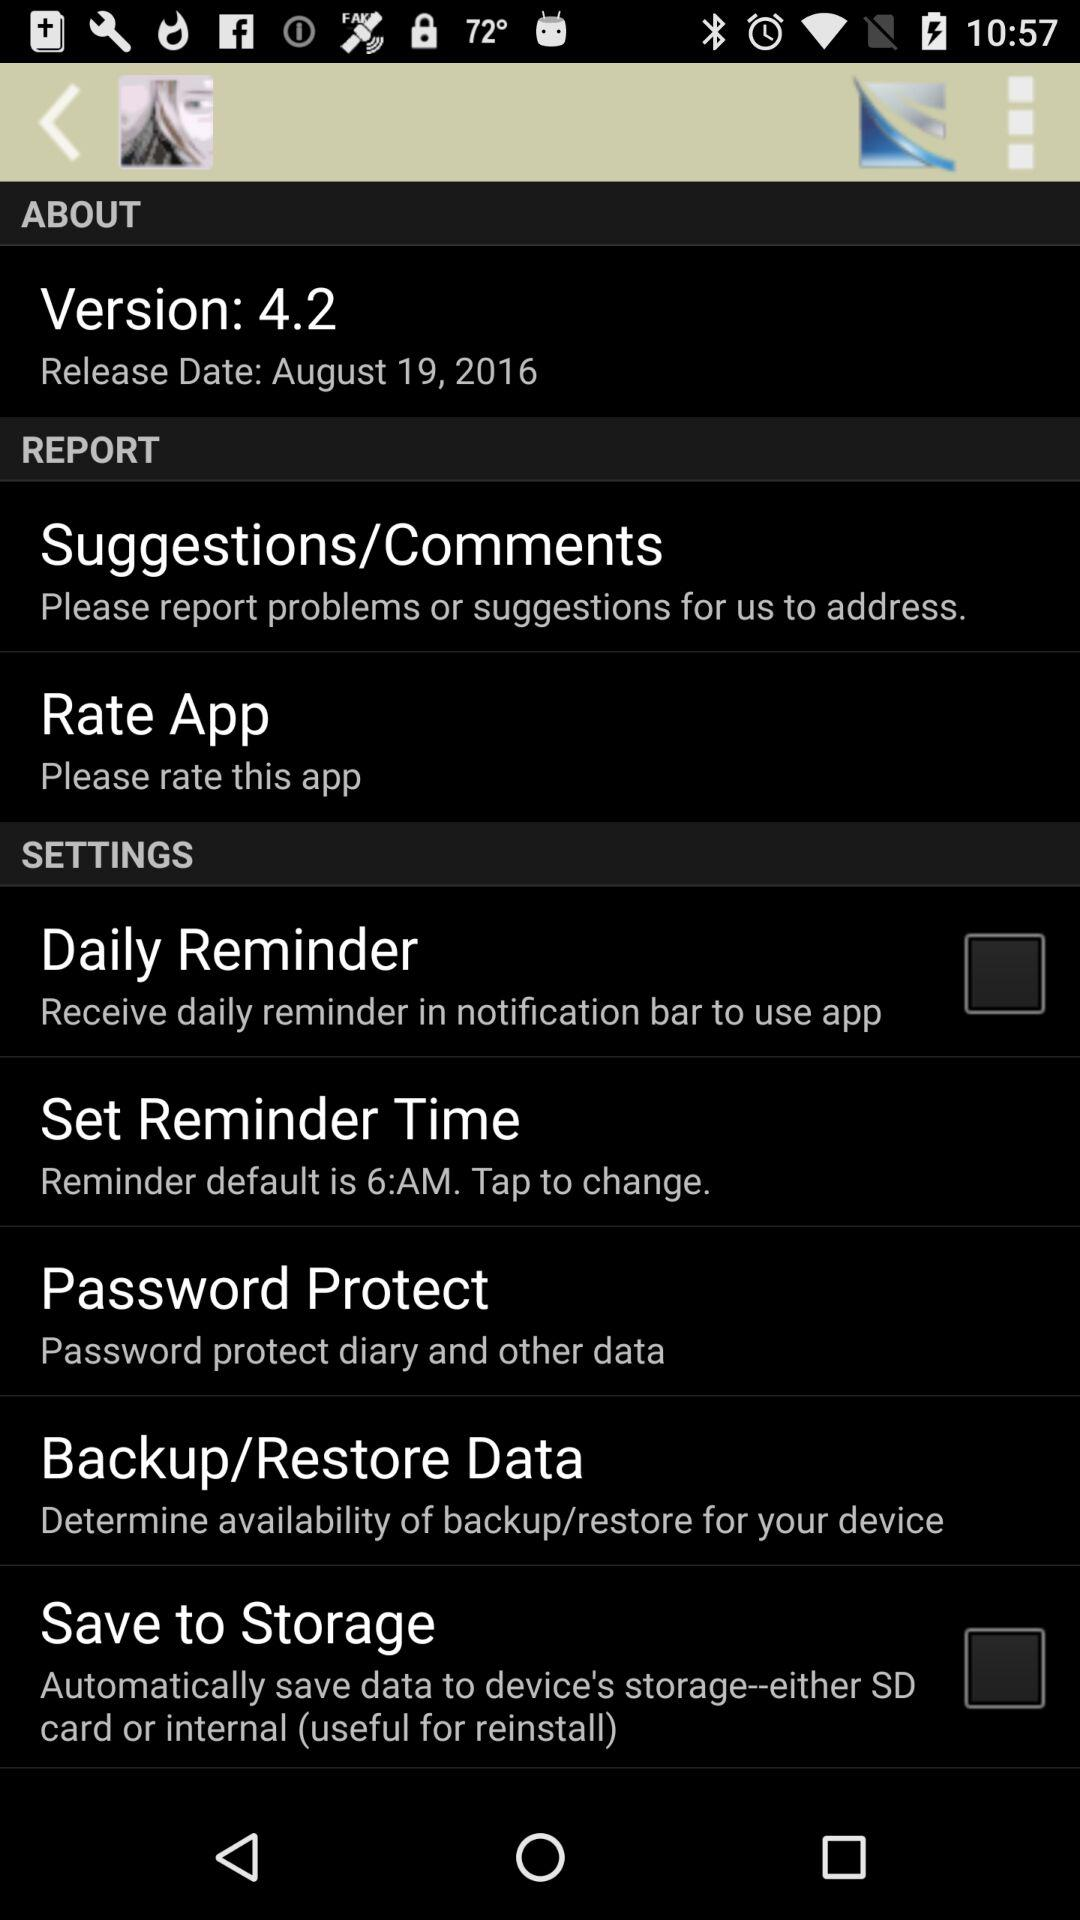What is the status of "Daily Reminder"? The status is "off". 